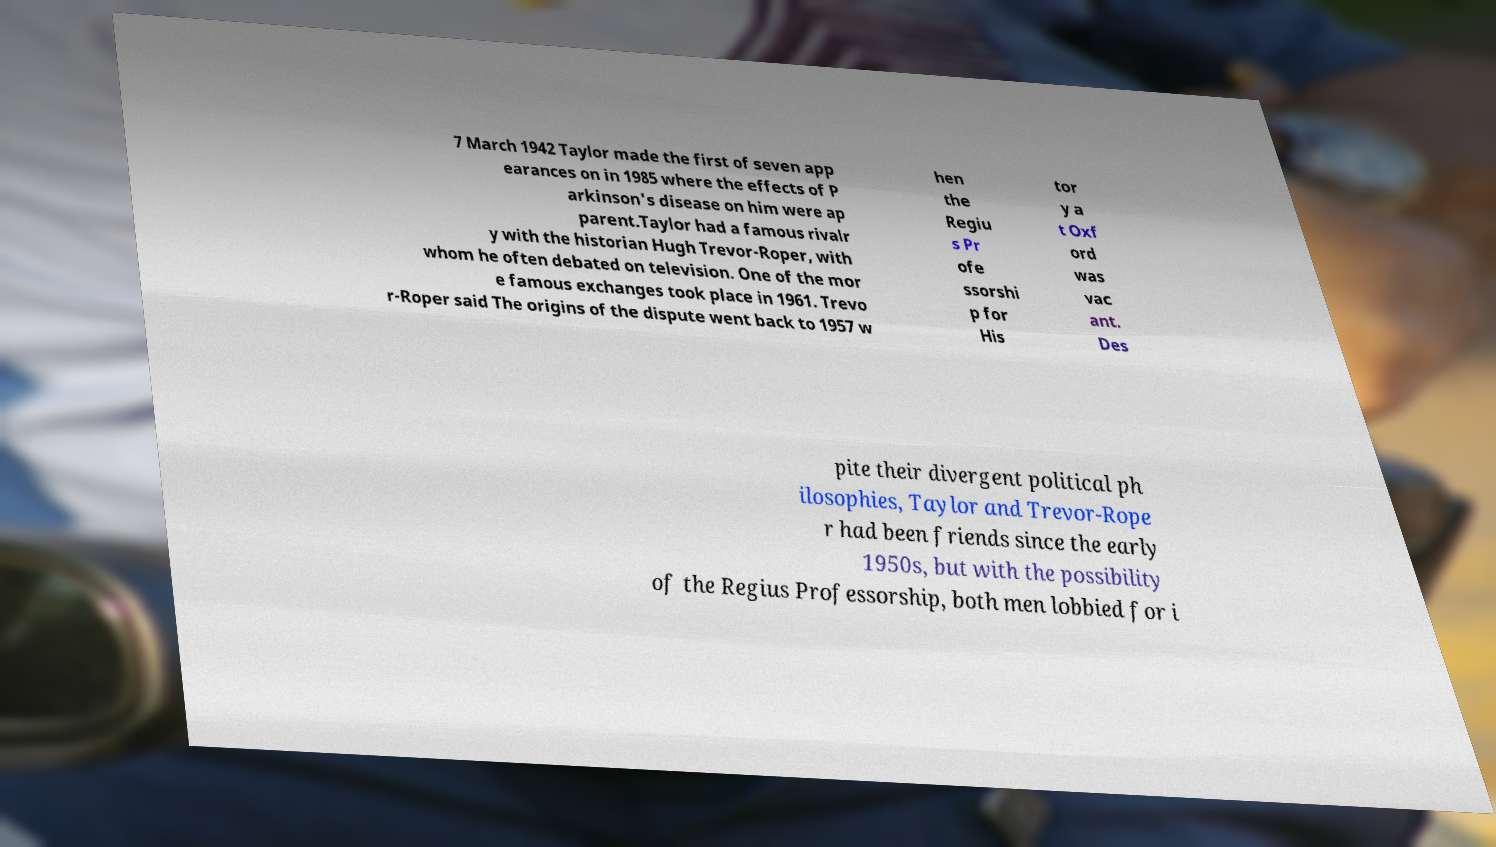What messages or text are displayed in this image? I need them in a readable, typed format. 7 March 1942 Taylor made the first of seven app earances on in 1985 where the effects of P arkinson's disease on him were ap parent.Taylor had a famous rivalr y with the historian Hugh Trevor-Roper, with whom he often debated on television. One of the mor e famous exchanges took place in 1961. Trevo r-Roper said The origins of the dispute went back to 1957 w hen the Regiu s Pr ofe ssorshi p for His tor y a t Oxf ord was vac ant. Des pite their divergent political ph ilosophies, Taylor and Trevor-Rope r had been friends since the early 1950s, but with the possibility of the Regius Professorship, both men lobbied for i 